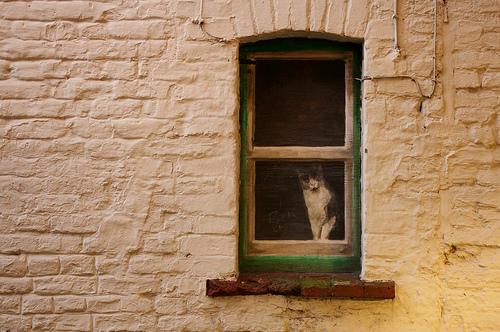Can the cats right eye be seen?
Concise answer only. Yes. Can the cat get out through the window?
Short answer required. No. What is staring out of the window?
Be succinct. Cat. What is the wall made of?
Write a very short answer. Brick. Is the windowsill made out of wood?
Write a very short answer. Yes. 